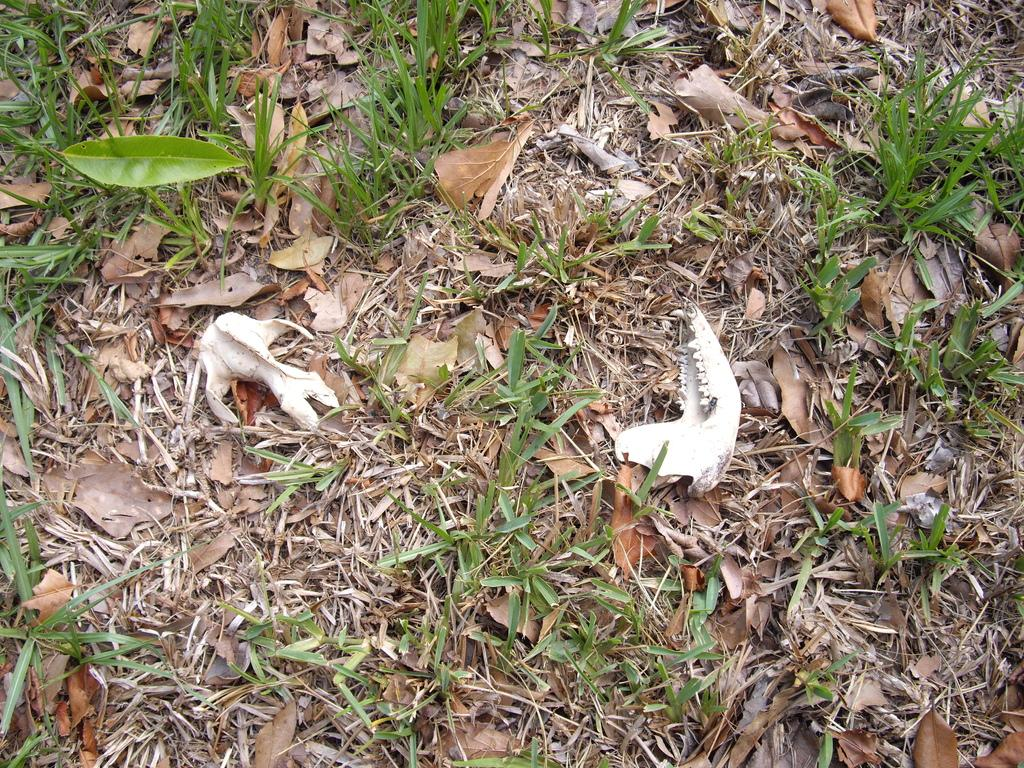What are the two white objects placed on the floor in the image? The image shows two white objects placed on the floor. What type of natural environment is visible in the image? There is grass visible in the image, which suggests a natural outdoor setting. What else can be seen in the image besides the grass? There are leaves in the image, as well as dry leaves on the floor. What type of cheese can be seen on the train in the image? There is no cheese or train present in the image. Can you tell me how many sisters are visible in the image? There are no people, let alone sisters, visible in the image. 